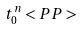<formula> <loc_0><loc_0><loc_500><loc_500>t ^ { n } _ { 0 } < P P ></formula> 